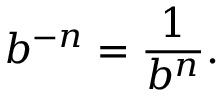Convert formula to latex. <formula><loc_0><loc_0><loc_500><loc_500>b ^ { - n } = { \frac { 1 } { b ^ { n } } } .</formula> 